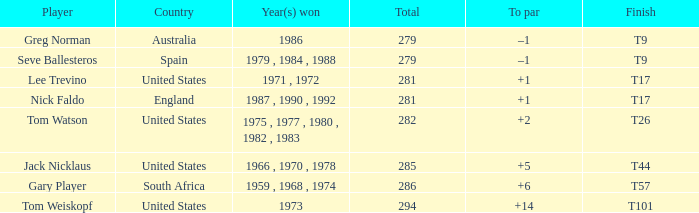Which competitor is from australia? Greg Norman. 